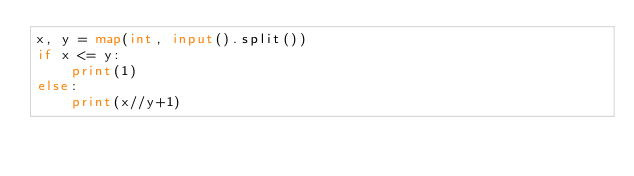<code> <loc_0><loc_0><loc_500><loc_500><_Python_>x, y = map(int, input().split())
if x <= y:
    print(1)
else:
    print(x//y+1)
</code> 